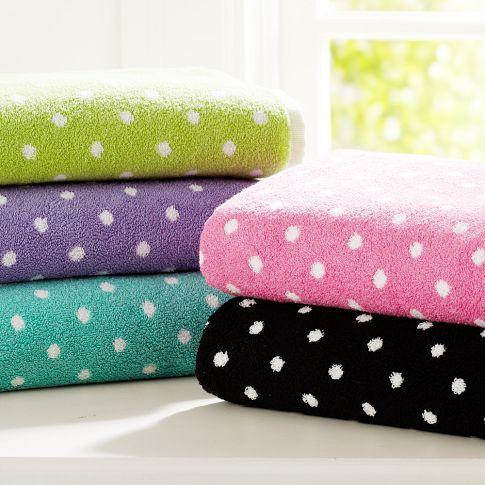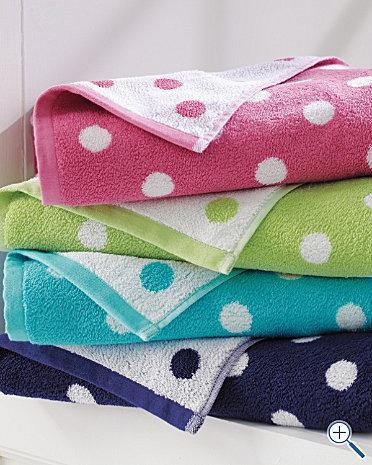The first image is the image on the left, the second image is the image on the right. Considering the images on both sides, is "A black towel is folded under a green folded towel." valid? Answer yes or no. No. The first image is the image on the left, the second image is the image on the right. Evaluate the accuracy of this statement regarding the images: "All images contain towels with a spotted pattern.". Is it true? Answer yes or no. Yes. 